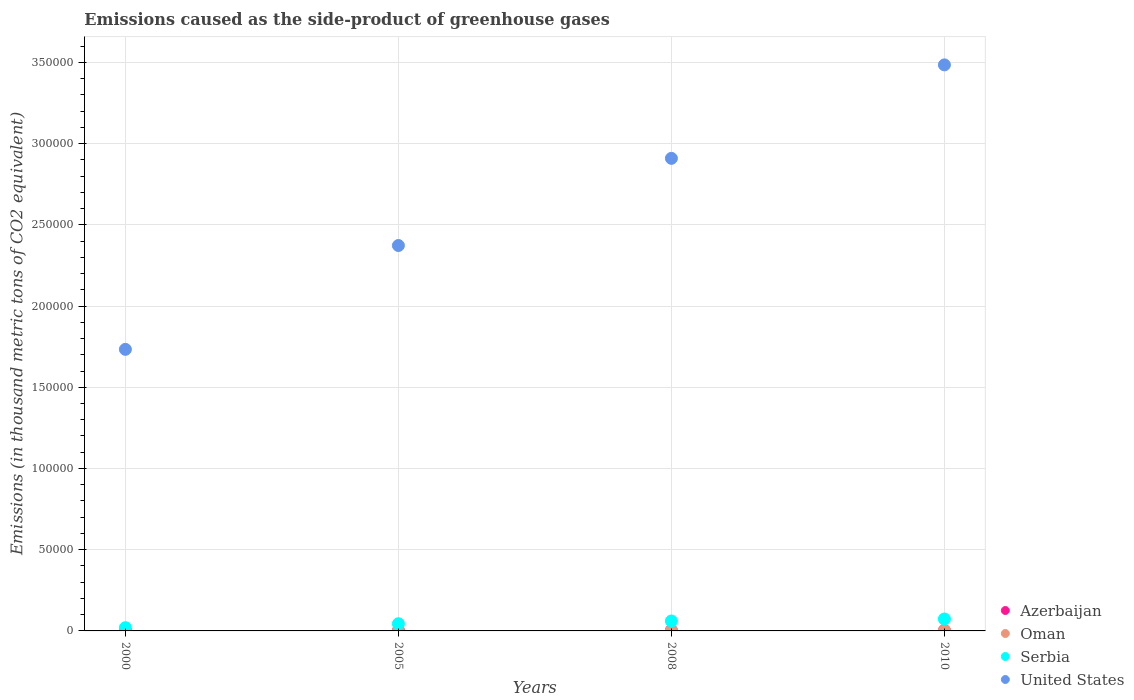Is the number of dotlines equal to the number of legend labels?
Make the answer very short. Yes. What is the emissions caused as the side-product of greenhouse gases in Serbia in 2000?
Provide a short and direct response. 1968.1. Across all years, what is the maximum emissions caused as the side-product of greenhouse gases in Oman?
Ensure brevity in your answer.  361. Across all years, what is the minimum emissions caused as the side-product of greenhouse gases in United States?
Provide a short and direct response. 1.73e+05. In which year was the emissions caused as the side-product of greenhouse gases in Oman maximum?
Ensure brevity in your answer.  2010. What is the total emissions caused as the side-product of greenhouse gases in Oman in the graph?
Offer a terse response. 810.1. What is the difference between the emissions caused as the side-product of greenhouse gases in Serbia in 2000 and that in 2008?
Your answer should be compact. -4143.2. What is the difference between the emissions caused as the side-product of greenhouse gases in United States in 2005 and the emissions caused as the side-product of greenhouse gases in Azerbaijan in 2000?
Provide a succinct answer. 2.37e+05. What is the average emissions caused as the side-product of greenhouse gases in United States per year?
Ensure brevity in your answer.  2.62e+05. In the year 2005, what is the difference between the emissions caused as the side-product of greenhouse gases in Azerbaijan and emissions caused as the side-product of greenhouse gases in Oman?
Make the answer very short. 91.5. What is the ratio of the emissions caused as the side-product of greenhouse gases in Azerbaijan in 2005 to that in 2008?
Your answer should be compact. 0.79. Is the difference between the emissions caused as the side-product of greenhouse gases in Azerbaijan in 2000 and 2010 greater than the difference between the emissions caused as the side-product of greenhouse gases in Oman in 2000 and 2010?
Provide a succinct answer. Yes. What is the difference between the highest and the second highest emissions caused as the side-product of greenhouse gases in Azerbaijan?
Offer a terse response. 52.3. What is the difference between the highest and the lowest emissions caused as the side-product of greenhouse gases in Serbia?
Your answer should be very brief. 5369.9. In how many years, is the emissions caused as the side-product of greenhouse gases in Azerbaijan greater than the average emissions caused as the side-product of greenhouse gases in Azerbaijan taken over all years?
Keep it short and to the point. 3. Is the emissions caused as the side-product of greenhouse gases in Oman strictly greater than the emissions caused as the side-product of greenhouse gases in Azerbaijan over the years?
Keep it short and to the point. No. Is the emissions caused as the side-product of greenhouse gases in United States strictly less than the emissions caused as the side-product of greenhouse gases in Serbia over the years?
Give a very brief answer. No. How many years are there in the graph?
Your response must be concise. 4. What is the difference between two consecutive major ticks on the Y-axis?
Your response must be concise. 5.00e+04. How many legend labels are there?
Offer a terse response. 4. What is the title of the graph?
Your answer should be compact. Emissions caused as the side-product of greenhouse gases. Does "Latin America(developing only)" appear as one of the legend labels in the graph?
Offer a terse response. No. What is the label or title of the Y-axis?
Ensure brevity in your answer.  Emissions (in thousand metric tons of CO2 equivalent). What is the Emissions (in thousand metric tons of CO2 equivalent) in Azerbaijan in 2000?
Provide a short and direct response. 41.3. What is the Emissions (in thousand metric tons of CO2 equivalent) of Serbia in 2000?
Give a very brief answer. 1968.1. What is the Emissions (in thousand metric tons of CO2 equivalent) in United States in 2000?
Give a very brief answer. 1.73e+05. What is the Emissions (in thousand metric tons of CO2 equivalent) in Azerbaijan in 2005?
Keep it short and to the point. 265.1. What is the Emissions (in thousand metric tons of CO2 equivalent) of Oman in 2005?
Your response must be concise. 173.6. What is the Emissions (in thousand metric tons of CO2 equivalent) in Serbia in 2005?
Provide a succinct answer. 4422.8. What is the Emissions (in thousand metric tons of CO2 equivalent) in United States in 2005?
Your response must be concise. 2.37e+05. What is the Emissions (in thousand metric tons of CO2 equivalent) in Azerbaijan in 2008?
Offer a terse response. 335.3. What is the Emissions (in thousand metric tons of CO2 equivalent) of Oman in 2008?
Offer a terse response. 266.9. What is the Emissions (in thousand metric tons of CO2 equivalent) of Serbia in 2008?
Provide a succinct answer. 6111.3. What is the Emissions (in thousand metric tons of CO2 equivalent) in United States in 2008?
Your response must be concise. 2.91e+05. What is the Emissions (in thousand metric tons of CO2 equivalent) in Azerbaijan in 2010?
Offer a terse response. 283. What is the Emissions (in thousand metric tons of CO2 equivalent) of Oman in 2010?
Make the answer very short. 361. What is the Emissions (in thousand metric tons of CO2 equivalent) in Serbia in 2010?
Offer a terse response. 7338. What is the Emissions (in thousand metric tons of CO2 equivalent) in United States in 2010?
Ensure brevity in your answer.  3.48e+05. Across all years, what is the maximum Emissions (in thousand metric tons of CO2 equivalent) of Azerbaijan?
Offer a very short reply. 335.3. Across all years, what is the maximum Emissions (in thousand metric tons of CO2 equivalent) in Oman?
Offer a very short reply. 361. Across all years, what is the maximum Emissions (in thousand metric tons of CO2 equivalent) of Serbia?
Your response must be concise. 7338. Across all years, what is the maximum Emissions (in thousand metric tons of CO2 equivalent) in United States?
Your answer should be compact. 3.48e+05. Across all years, what is the minimum Emissions (in thousand metric tons of CO2 equivalent) in Azerbaijan?
Keep it short and to the point. 41.3. Across all years, what is the minimum Emissions (in thousand metric tons of CO2 equivalent) of Serbia?
Your response must be concise. 1968.1. Across all years, what is the minimum Emissions (in thousand metric tons of CO2 equivalent) in United States?
Provide a succinct answer. 1.73e+05. What is the total Emissions (in thousand metric tons of CO2 equivalent) in Azerbaijan in the graph?
Provide a succinct answer. 924.7. What is the total Emissions (in thousand metric tons of CO2 equivalent) of Oman in the graph?
Provide a succinct answer. 810.1. What is the total Emissions (in thousand metric tons of CO2 equivalent) in Serbia in the graph?
Your answer should be very brief. 1.98e+04. What is the total Emissions (in thousand metric tons of CO2 equivalent) in United States in the graph?
Your answer should be very brief. 1.05e+06. What is the difference between the Emissions (in thousand metric tons of CO2 equivalent) of Azerbaijan in 2000 and that in 2005?
Your response must be concise. -223.8. What is the difference between the Emissions (in thousand metric tons of CO2 equivalent) in Oman in 2000 and that in 2005?
Offer a terse response. -165. What is the difference between the Emissions (in thousand metric tons of CO2 equivalent) of Serbia in 2000 and that in 2005?
Make the answer very short. -2454.7. What is the difference between the Emissions (in thousand metric tons of CO2 equivalent) in United States in 2000 and that in 2005?
Your answer should be very brief. -6.39e+04. What is the difference between the Emissions (in thousand metric tons of CO2 equivalent) in Azerbaijan in 2000 and that in 2008?
Provide a succinct answer. -294. What is the difference between the Emissions (in thousand metric tons of CO2 equivalent) of Oman in 2000 and that in 2008?
Offer a terse response. -258.3. What is the difference between the Emissions (in thousand metric tons of CO2 equivalent) in Serbia in 2000 and that in 2008?
Ensure brevity in your answer.  -4143.2. What is the difference between the Emissions (in thousand metric tons of CO2 equivalent) of United States in 2000 and that in 2008?
Offer a terse response. -1.18e+05. What is the difference between the Emissions (in thousand metric tons of CO2 equivalent) of Azerbaijan in 2000 and that in 2010?
Keep it short and to the point. -241.7. What is the difference between the Emissions (in thousand metric tons of CO2 equivalent) of Oman in 2000 and that in 2010?
Your answer should be compact. -352.4. What is the difference between the Emissions (in thousand metric tons of CO2 equivalent) in Serbia in 2000 and that in 2010?
Make the answer very short. -5369.9. What is the difference between the Emissions (in thousand metric tons of CO2 equivalent) of United States in 2000 and that in 2010?
Offer a terse response. -1.75e+05. What is the difference between the Emissions (in thousand metric tons of CO2 equivalent) of Azerbaijan in 2005 and that in 2008?
Offer a terse response. -70.2. What is the difference between the Emissions (in thousand metric tons of CO2 equivalent) in Oman in 2005 and that in 2008?
Offer a terse response. -93.3. What is the difference between the Emissions (in thousand metric tons of CO2 equivalent) in Serbia in 2005 and that in 2008?
Make the answer very short. -1688.5. What is the difference between the Emissions (in thousand metric tons of CO2 equivalent) in United States in 2005 and that in 2008?
Ensure brevity in your answer.  -5.37e+04. What is the difference between the Emissions (in thousand metric tons of CO2 equivalent) of Azerbaijan in 2005 and that in 2010?
Offer a very short reply. -17.9. What is the difference between the Emissions (in thousand metric tons of CO2 equivalent) in Oman in 2005 and that in 2010?
Offer a very short reply. -187.4. What is the difference between the Emissions (in thousand metric tons of CO2 equivalent) in Serbia in 2005 and that in 2010?
Offer a very short reply. -2915.2. What is the difference between the Emissions (in thousand metric tons of CO2 equivalent) of United States in 2005 and that in 2010?
Provide a short and direct response. -1.11e+05. What is the difference between the Emissions (in thousand metric tons of CO2 equivalent) of Azerbaijan in 2008 and that in 2010?
Your answer should be very brief. 52.3. What is the difference between the Emissions (in thousand metric tons of CO2 equivalent) in Oman in 2008 and that in 2010?
Your answer should be compact. -94.1. What is the difference between the Emissions (in thousand metric tons of CO2 equivalent) in Serbia in 2008 and that in 2010?
Give a very brief answer. -1226.7. What is the difference between the Emissions (in thousand metric tons of CO2 equivalent) of United States in 2008 and that in 2010?
Keep it short and to the point. -5.75e+04. What is the difference between the Emissions (in thousand metric tons of CO2 equivalent) of Azerbaijan in 2000 and the Emissions (in thousand metric tons of CO2 equivalent) of Oman in 2005?
Provide a succinct answer. -132.3. What is the difference between the Emissions (in thousand metric tons of CO2 equivalent) in Azerbaijan in 2000 and the Emissions (in thousand metric tons of CO2 equivalent) in Serbia in 2005?
Make the answer very short. -4381.5. What is the difference between the Emissions (in thousand metric tons of CO2 equivalent) in Azerbaijan in 2000 and the Emissions (in thousand metric tons of CO2 equivalent) in United States in 2005?
Ensure brevity in your answer.  -2.37e+05. What is the difference between the Emissions (in thousand metric tons of CO2 equivalent) of Oman in 2000 and the Emissions (in thousand metric tons of CO2 equivalent) of Serbia in 2005?
Your answer should be compact. -4414.2. What is the difference between the Emissions (in thousand metric tons of CO2 equivalent) of Oman in 2000 and the Emissions (in thousand metric tons of CO2 equivalent) of United States in 2005?
Keep it short and to the point. -2.37e+05. What is the difference between the Emissions (in thousand metric tons of CO2 equivalent) of Serbia in 2000 and the Emissions (in thousand metric tons of CO2 equivalent) of United States in 2005?
Keep it short and to the point. -2.35e+05. What is the difference between the Emissions (in thousand metric tons of CO2 equivalent) of Azerbaijan in 2000 and the Emissions (in thousand metric tons of CO2 equivalent) of Oman in 2008?
Your answer should be compact. -225.6. What is the difference between the Emissions (in thousand metric tons of CO2 equivalent) of Azerbaijan in 2000 and the Emissions (in thousand metric tons of CO2 equivalent) of Serbia in 2008?
Keep it short and to the point. -6070. What is the difference between the Emissions (in thousand metric tons of CO2 equivalent) in Azerbaijan in 2000 and the Emissions (in thousand metric tons of CO2 equivalent) in United States in 2008?
Offer a terse response. -2.91e+05. What is the difference between the Emissions (in thousand metric tons of CO2 equivalent) in Oman in 2000 and the Emissions (in thousand metric tons of CO2 equivalent) in Serbia in 2008?
Offer a very short reply. -6102.7. What is the difference between the Emissions (in thousand metric tons of CO2 equivalent) of Oman in 2000 and the Emissions (in thousand metric tons of CO2 equivalent) of United States in 2008?
Your answer should be very brief. -2.91e+05. What is the difference between the Emissions (in thousand metric tons of CO2 equivalent) in Serbia in 2000 and the Emissions (in thousand metric tons of CO2 equivalent) in United States in 2008?
Ensure brevity in your answer.  -2.89e+05. What is the difference between the Emissions (in thousand metric tons of CO2 equivalent) of Azerbaijan in 2000 and the Emissions (in thousand metric tons of CO2 equivalent) of Oman in 2010?
Your response must be concise. -319.7. What is the difference between the Emissions (in thousand metric tons of CO2 equivalent) of Azerbaijan in 2000 and the Emissions (in thousand metric tons of CO2 equivalent) of Serbia in 2010?
Offer a very short reply. -7296.7. What is the difference between the Emissions (in thousand metric tons of CO2 equivalent) in Azerbaijan in 2000 and the Emissions (in thousand metric tons of CO2 equivalent) in United States in 2010?
Your response must be concise. -3.48e+05. What is the difference between the Emissions (in thousand metric tons of CO2 equivalent) in Oman in 2000 and the Emissions (in thousand metric tons of CO2 equivalent) in Serbia in 2010?
Your answer should be very brief. -7329.4. What is the difference between the Emissions (in thousand metric tons of CO2 equivalent) of Oman in 2000 and the Emissions (in thousand metric tons of CO2 equivalent) of United States in 2010?
Your answer should be very brief. -3.48e+05. What is the difference between the Emissions (in thousand metric tons of CO2 equivalent) in Serbia in 2000 and the Emissions (in thousand metric tons of CO2 equivalent) in United States in 2010?
Make the answer very short. -3.46e+05. What is the difference between the Emissions (in thousand metric tons of CO2 equivalent) in Azerbaijan in 2005 and the Emissions (in thousand metric tons of CO2 equivalent) in Serbia in 2008?
Provide a short and direct response. -5846.2. What is the difference between the Emissions (in thousand metric tons of CO2 equivalent) of Azerbaijan in 2005 and the Emissions (in thousand metric tons of CO2 equivalent) of United States in 2008?
Keep it short and to the point. -2.91e+05. What is the difference between the Emissions (in thousand metric tons of CO2 equivalent) of Oman in 2005 and the Emissions (in thousand metric tons of CO2 equivalent) of Serbia in 2008?
Offer a terse response. -5937.7. What is the difference between the Emissions (in thousand metric tons of CO2 equivalent) in Oman in 2005 and the Emissions (in thousand metric tons of CO2 equivalent) in United States in 2008?
Provide a short and direct response. -2.91e+05. What is the difference between the Emissions (in thousand metric tons of CO2 equivalent) of Serbia in 2005 and the Emissions (in thousand metric tons of CO2 equivalent) of United States in 2008?
Provide a short and direct response. -2.86e+05. What is the difference between the Emissions (in thousand metric tons of CO2 equivalent) in Azerbaijan in 2005 and the Emissions (in thousand metric tons of CO2 equivalent) in Oman in 2010?
Your answer should be very brief. -95.9. What is the difference between the Emissions (in thousand metric tons of CO2 equivalent) in Azerbaijan in 2005 and the Emissions (in thousand metric tons of CO2 equivalent) in Serbia in 2010?
Your answer should be compact. -7072.9. What is the difference between the Emissions (in thousand metric tons of CO2 equivalent) of Azerbaijan in 2005 and the Emissions (in thousand metric tons of CO2 equivalent) of United States in 2010?
Provide a succinct answer. -3.48e+05. What is the difference between the Emissions (in thousand metric tons of CO2 equivalent) in Oman in 2005 and the Emissions (in thousand metric tons of CO2 equivalent) in Serbia in 2010?
Make the answer very short. -7164.4. What is the difference between the Emissions (in thousand metric tons of CO2 equivalent) of Oman in 2005 and the Emissions (in thousand metric tons of CO2 equivalent) of United States in 2010?
Keep it short and to the point. -3.48e+05. What is the difference between the Emissions (in thousand metric tons of CO2 equivalent) of Serbia in 2005 and the Emissions (in thousand metric tons of CO2 equivalent) of United States in 2010?
Provide a short and direct response. -3.44e+05. What is the difference between the Emissions (in thousand metric tons of CO2 equivalent) in Azerbaijan in 2008 and the Emissions (in thousand metric tons of CO2 equivalent) in Oman in 2010?
Your answer should be very brief. -25.7. What is the difference between the Emissions (in thousand metric tons of CO2 equivalent) of Azerbaijan in 2008 and the Emissions (in thousand metric tons of CO2 equivalent) of Serbia in 2010?
Offer a very short reply. -7002.7. What is the difference between the Emissions (in thousand metric tons of CO2 equivalent) of Azerbaijan in 2008 and the Emissions (in thousand metric tons of CO2 equivalent) of United States in 2010?
Provide a short and direct response. -3.48e+05. What is the difference between the Emissions (in thousand metric tons of CO2 equivalent) in Oman in 2008 and the Emissions (in thousand metric tons of CO2 equivalent) in Serbia in 2010?
Offer a terse response. -7071.1. What is the difference between the Emissions (in thousand metric tons of CO2 equivalent) in Oman in 2008 and the Emissions (in thousand metric tons of CO2 equivalent) in United States in 2010?
Your answer should be compact. -3.48e+05. What is the difference between the Emissions (in thousand metric tons of CO2 equivalent) of Serbia in 2008 and the Emissions (in thousand metric tons of CO2 equivalent) of United States in 2010?
Provide a succinct answer. -3.42e+05. What is the average Emissions (in thousand metric tons of CO2 equivalent) in Azerbaijan per year?
Your response must be concise. 231.18. What is the average Emissions (in thousand metric tons of CO2 equivalent) of Oman per year?
Ensure brevity in your answer.  202.53. What is the average Emissions (in thousand metric tons of CO2 equivalent) of Serbia per year?
Make the answer very short. 4960.05. What is the average Emissions (in thousand metric tons of CO2 equivalent) in United States per year?
Keep it short and to the point. 2.62e+05. In the year 2000, what is the difference between the Emissions (in thousand metric tons of CO2 equivalent) in Azerbaijan and Emissions (in thousand metric tons of CO2 equivalent) in Oman?
Your answer should be compact. 32.7. In the year 2000, what is the difference between the Emissions (in thousand metric tons of CO2 equivalent) of Azerbaijan and Emissions (in thousand metric tons of CO2 equivalent) of Serbia?
Give a very brief answer. -1926.8. In the year 2000, what is the difference between the Emissions (in thousand metric tons of CO2 equivalent) of Azerbaijan and Emissions (in thousand metric tons of CO2 equivalent) of United States?
Your answer should be compact. -1.73e+05. In the year 2000, what is the difference between the Emissions (in thousand metric tons of CO2 equivalent) of Oman and Emissions (in thousand metric tons of CO2 equivalent) of Serbia?
Provide a short and direct response. -1959.5. In the year 2000, what is the difference between the Emissions (in thousand metric tons of CO2 equivalent) of Oman and Emissions (in thousand metric tons of CO2 equivalent) of United States?
Your response must be concise. -1.73e+05. In the year 2000, what is the difference between the Emissions (in thousand metric tons of CO2 equivalent) of Serbia and Emissions (in thousand metric tons of CO2 equivalent) of United States?
Keep it short and to the point. -1.71e+05. In the year 2005, what is the difference between the Emissions (in thousand metric tons of CO2 equivalent) of Azerbaijan and Emissions (in thousand metric tons of CO2 equivalent) of Oman?
Keep it short and to the point. 91.5. In the year 2005, what is the difference between the Emissions (in thousand metric tons of CO2 equivalent) in Azerbaijan and Emissions (in thousand metric tons of CO2 equivalent) in Serbia?
Your answer should be compact. -4157.7. In the year 2005, what is the difference between the Emissions (in thousand metric tons of CO2 equivalent) in Azerbaijan and Emissions (in thousand metric tons of CO2 equivalent) in United States?
Your answer should be compact. -2.37e+05. In the year 2005, what is the difference between the Emissions (in thousand metric tons of CO2 equivalent) in Oman and Emissions (in thousand metric tons of CO2 equivalent) in Serbia?
Offer a very short reply. -4249.2. In the year 2005, what is the difference between the Emissions (in thousand metric tons of CO2 equivalent) of Oman and Emissions (in thousand metric tons of CO2 equivalent) of United States?
Give a very brief answer. -2.37e+05. In the year 2005, what is the difference between the Emissions (in thousand metric tons of CO2 equivalent) of Serbia and Emissions (in thousand metric tons of CO2 equivalent) of United States?
Provide a short and direct response. -2.33e+05. In the year 2008, what is the difference between the Emissions (in thousand metric tons of CO2 equivalent) in Azerbaijan and Emissions (in thousand metric tons of CO2 equivalent) in Oman?
Your response must be concise. 68.4. In the year 2008, what is the difference between the Emissions (in thousand metric tons of CO2 equivalent) in Azerbaijan and Emissions (in thousand metric tons of CO2 equivalent) in Serbia?
Provide a short and direct response. -5776. In the year 2008, what is the difference between the Emissions (in thousand metric tons of CO2 equivalent) of Azerbaijan and Emissions (in thousand metric tons of CO2 equivalent) of United States?
Provide a short and direct response. -2.91e+05. In the year 2008, what is the difference between the Emissions (in thousand metric tons of CO2 equivalent) in Oman and Emissions (in thousand metric tons of CO2 equivalent) in Serbia?
Your response must be concise. -5844.4. In the year 2008, what is the difference between the Emissions (in thousand metric tons of CO2 equivalent) in Oman and Emissions (in thousand metric tons of CO2 equivalent) in United States?
Keep it short and to the point. -2.91e+05. In the year 2008, what is the difference between the Emissions (in thousand metric tons of CO2 equivalent) of Serbia and Emissions (in thousand metric tons of CO2 equivalent) of United States?
Make the answer very short. -2.85e+05. In the year 2010, what is the difference between the Emissions (in thousand metric tons of CO2 equivalent) in Azerbaijan and Emissions (in thousand metric tons of CO2 equivalent) in Oman?
Your response must be concise. -78. In the year 2010, what is the difference between the Emissions (in thousand metric tons of CO2 equivalent) in Azerbaijan and Emissions (in thousand metric tons of CO2 equivalent) in Serbia?
Offer a terse response. -7055. In the year 2010, what is the difference between the Emissions (in thousand metric tons of CO2 equivalent) in Azerbaijan and Emissions (in thousand metric tons of CO2 equivalent) in United States?
Your answer should be compact. -3.48e+05. In the year 2010, what is the difference between the Emissions (in thousand metric tons of CO2 equivalent) in Oman and Emissions (in thousand metric tons of CO2 equivalent) in Serbia?
Make the answer very short. -6977. In the year 2010, what is the difference between the Emissions (in thousand metric tons of CO2 equivalent) of Oman and Emissions (in thousand metric tons of CO2 equivalent) of United States?
Offer a terse response. -3.48e+05. In the year 2010, what is the difference between the Emissions (in thousand metric tons of CO2 equivalent) of Serbia and Emissions (in thousand metric tons of CO2 equivalent) of United States?
Give a very brief answer. -3.41e+05. What is the ratio of the Emissions (in thousand metric tons of CO2 equivalent) of Azerbaijan in 2000 to that in 2005?
Provide a succinct answer. 0.16. What is the ratio of the Emissions (in thousand metric tons of CO2 equivalent) in Oman in 2000 to that in 2005?
Give a very brief answer. 0.05. What is the ratio of the Emissions (in thousand metric tons of CO2 equivalent) in Serbia in 2000 to that in 2005?
Provide a short and direct response. 0.45. What is the ratio of the Emissions (in thousand metric tons of CO2 equivalent) in United States in 2000 to that in 2005?
Ensure brevity in your answer.  0.73. What is the ratio of the Emissions (in thousand metric tons of CO2 equivalent) of Azerbaijan in 2000 to that in 2008?
Give a very brief answer. 0.12. What is the ratio of the Emissions (in thousand metric tons of CO2 equivalent) of Oman in 2000 to that in 2008?
Your answer should be compact. 0.03. What is the ratio of the Emissions (in thousand metric tons of CO2 equivalent) of Serbia in 2000 to that in 2008?
Offer a terse response. 0.32. What is the ratio of the Emissions (in thousand metric tons of CO2 equivalent) in United States in 2000 to that in 2008?
Offer a terse response. 0.6. What is the ratio of the Emissions (in thousand metric tons of CO2 equivalent) in Azerbaijan in 2000 to that in 2010?
Ensure brevity in your answer.  0.15. What is the ratio of the Emissions (in thousand metric tons of CO2 equivalent) of Oman in 2000 to that in 2010?
Offer a terse response. 0.02. What is the ratio of the Emissions (in thousand metric tons of CO2 equivalent) in Serbia in 2000 to that in 2010?
Your answer should be very brief. 0.27. What is the ratio of the Emissions (in thousand metric tons of CO2 equivalent) of United States in 2000 to that in 2010?
Keep it short and to the point. 0.5. What is the ratio of the Emissions (in thousand metric tons of CO2 equivalent) of Azerbaijan in 2005 to that in 2008?
Your answer should be compact. 0.79. What is the ratio of the Emissions (in thousand metric tons of CO2 equivalent) of Oman in 2005 to that in 2008?
Ensure brevity in your answer.  0.65. What is the ratio of the Emissions (in thousand metric tons of CO2 equivalent) of Serbia in 2005 to that in 2008?
Offer a very short reply. 0.72. What is the ratio of the Emissions (in thousand metric tons of CO2 equivalent) of United States in 2005 to that in 2008?
Your response must be concise. 0.82. What is the ratio of the Emissions (in thousand metric tons of CO2 equivalent) in Azerbaijan in 2005 to that in 2010?
Ensure brevity in your answer.  0.94. What is the ratio of the Emissions (in thousand metric tons of CO2 equivalent) in Oman in 2005 to that in 2010?
Your response must be concise. 0.48. What is the ratio of the Emissions (in thousand metric tons of CO2 equivalent) of Serbia in 2005 to that in 2010?
Provide a succinct answer. 0.6. What is the ratio of the Emissions (in thousand metric tons of CO2 equivalent) in United States in 2005 to that in 2010?
Offer a very short reply. 0.68. What is the ratio of the Emissions (in thousand metric tons of CO2 equivalent) in Azerbaijan in 2008 to that in 2010?
Your response must be concise. 1.18. What is the ratio of the Emissions (in thousand metric tons of CO2 equivalent) in Oman in 2008 to that in 2010?
Make the answer very short. 0.74. What is the ratio of the Emissions (in thousand metric tons of CO2 equivalent) of Serbia in 2008 to that in 2010?
Offer a terse response. 0.83. What is the ratio of the Emissions (in thousand metric tons of CO2 equivalent) in United States in 2008 to that in 2010?
Your response must be concise. 0.83. What is the difference between the highest and the second highest Emissions (in thousand metric tons of CO2 equivalent) in Azerbaijan?
Provide a succinct answer. 52.3. What is the difference between the highest and the second highest Emissions (in thousand metric tons of CO2 equivalent) in Oman?
Give a very brief answer. 94.1. What is the difference between the highest and the second highest Emissions (in thousand metric tons of CO2 equivalent) of Serbia?
Offer a very short reply. 1226.7. What is the difference between the highest and the second highest Emissions (in thousand metric tons of CO2 equivalent) in United States?
Make the answer very short. 5.75e+04. What is the difference between the highest and the lowest Emissions (in thousand metric tons of CO2 equivalent) in Azerbaijan?
Provide a short and direct response. 294. What is the difference between the highest and the lowest Emissions (in thousand metric tons of CO2 equivalent) in Oman?
Your answer should be compact. 352.4. What is the difference between the highest and the lowest Emissions (in thousand metric tons of CO2 equivalent) of Serbia?
Make the answer very short. 5369.9. What is the difference between the highest and the lowest Emissions (in thousand metric tons of CO2 equivalent) in United States?
Provide a short and direct response. 1.75e+05. 